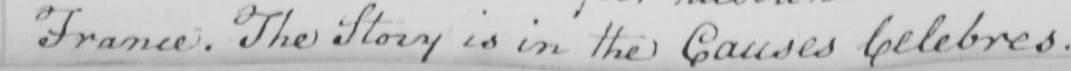Please provide the text content of this handwritten line. France . The Story is in the Causes Celebres . 